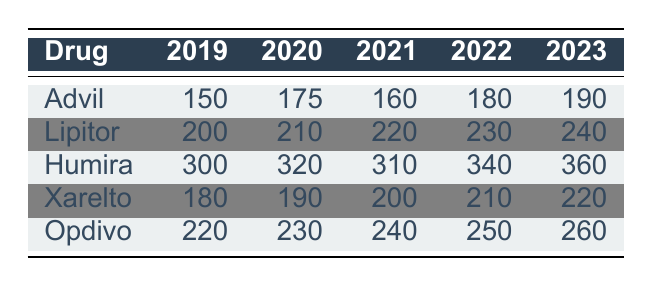What was the highest number of adverse event reports for Humira in a single year? Looking at the table, we see that Humira had the following reports: 300 in 2019, 320 in 2020, 310 in 2021, 340 in 2022, and 360 in 2023. The highest value is 360 in 2023.
Answer: 360 In which year did Lipitor have the least number of adverse event reports? Reviewing the table for Lipitor, the reports are: 200 in 2019, 210 in 2020, 220 in 2021, 230 in 2022, and 240 in 2023. The least number was 200 in 2019.
Answer: 2019 What is the total number of adverse event reports for Xarelto over the five years? Adding the reports for Xarelto: 180 (2019) + 190 (2020) + 200 (2021) + 210 (2022) + 220 (2023) equals 1,100.
Answer: 1100 Did Advil see an increase in adverse event reports every year? Listing Advil's reports shows: 150 in 2019, 175 in 2020, 160 in 2021, 180 in 2022, and 190 in 2023. There's a decrease from 2020 to 2021 (from 175 to 160), so the statement is false.
Answer: No What is the average number of adverse event reports for Opdivo over the five years? The reports for Opdivo are: 220 (2019), 230 (2020), 240 (2021), 250 (2022), and 260 (2023). Summing these gives: 220 + 230 + 240 + 250 + 260 = 1,200. Dividing by 5 results in an average of 240.
Answer: 240 Which drug had the highest total number of adverse event reports from 2019 to 2023? Calculating totals: Advil: 150 + 175 + 160 + 180 + 190 = 855; Lipitor: 200 + 210 + 220 + 230 + 240 = 1,100; Humira: 300 + 320 + 310 + 340 + 360 = 1,630; Xarelto: 180 + 190 + 200 + 210 + 220 = 1,100; Opdivo: 220 + 230 + 240 + 250 + 260 = 1,200. Humira has the highest total at 1,630.
Answer: Humira How many adverse event reports did Lipitor have in 2023 compared to 2019? Lipitor had 240 reports in 2023 and 200 in 2019. The difference is 240 - 200 = 40, meaning it increased by 40 reports.
Answer: 40 Based on the data, did any drug consistently increase its adverse event reports each year? Observing the trends, only Humira consistently increased from 300 (2019) to 360 (2023). Other drugs fluctuated or decreased at times.
Answer: Yes 